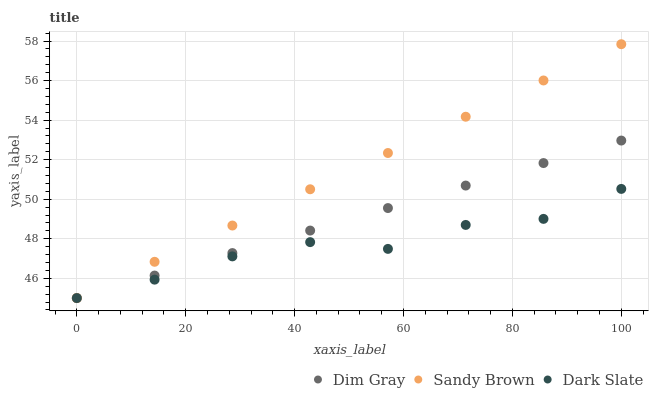Does Dark Slate have the minimum area under the curve?
Answer yes or no. Yes. Does Sandy Brown have the maximum area under the curve?
Answer yes or no. Yes. Does Dim Gray have the minimum area under the curve?
Answer yes or no. No. Does Dim Gray have the maximum area under the curve?
Answer yes or no. No. Is Sandy Brown the smoothest?
Answer yes or no. Yes. Is Dark Slate the roughest?
Answer yes or no. Yes. Is Dim Gray the smoothest?
Answer yes or no. No. Is Dim Gray the roughest?
Answer yes or no. No. Does Dark Slate have the lowest value?
Answer yes or no. Yes. Does Sandy Brown have the highest value?
Answer yes or no. Yes. Does Dim Gray have the highest value?
Answer yes or no. No. Does Dark Slate intersect Dim Gray?
Answer yes or no. Yes. Is Dark Slate less than Dim Gray?
Answer yes or no. No. Is Dark Slate greater than Dim Gray?
Answer yes or no. No. 